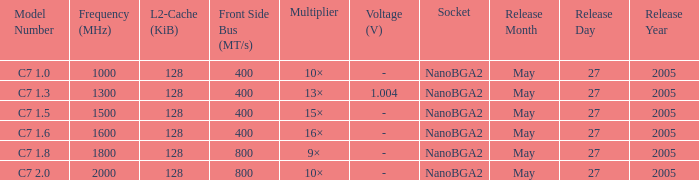What is the Release Date for Model Number c7 1.8? May 27, 2005. 